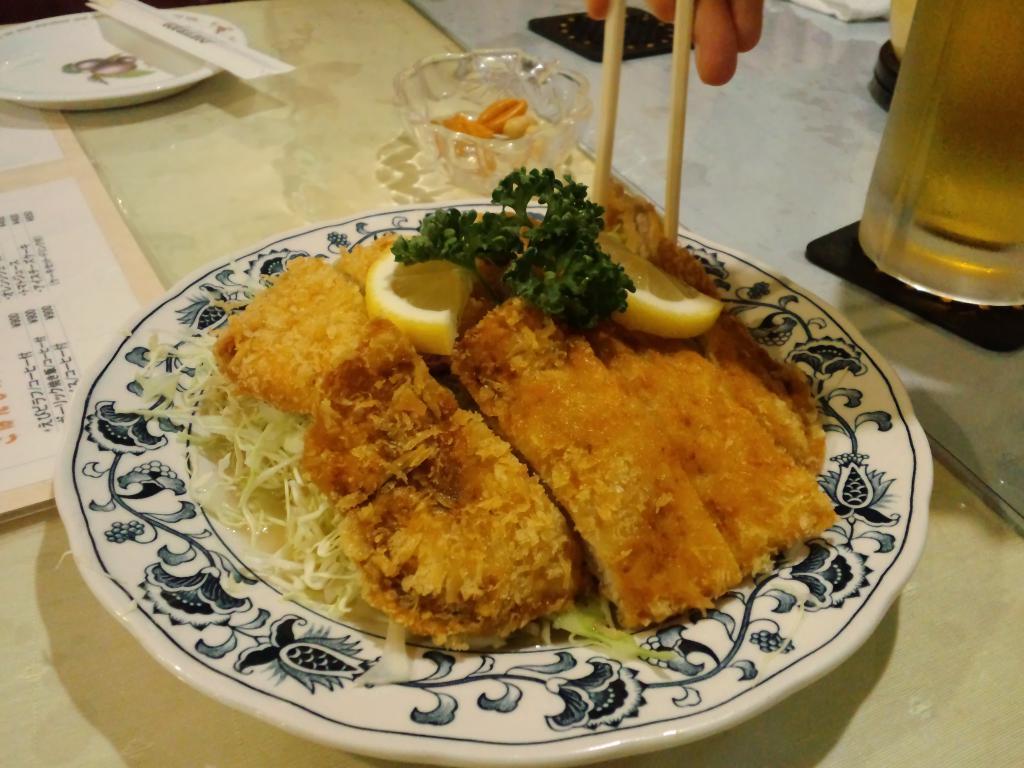In one or two sentences, can you explain what this image depicts? In this image we can see a table on which there is a plate in it there are food items. There are other objects on the table. At the top of the image there is person's hand. 